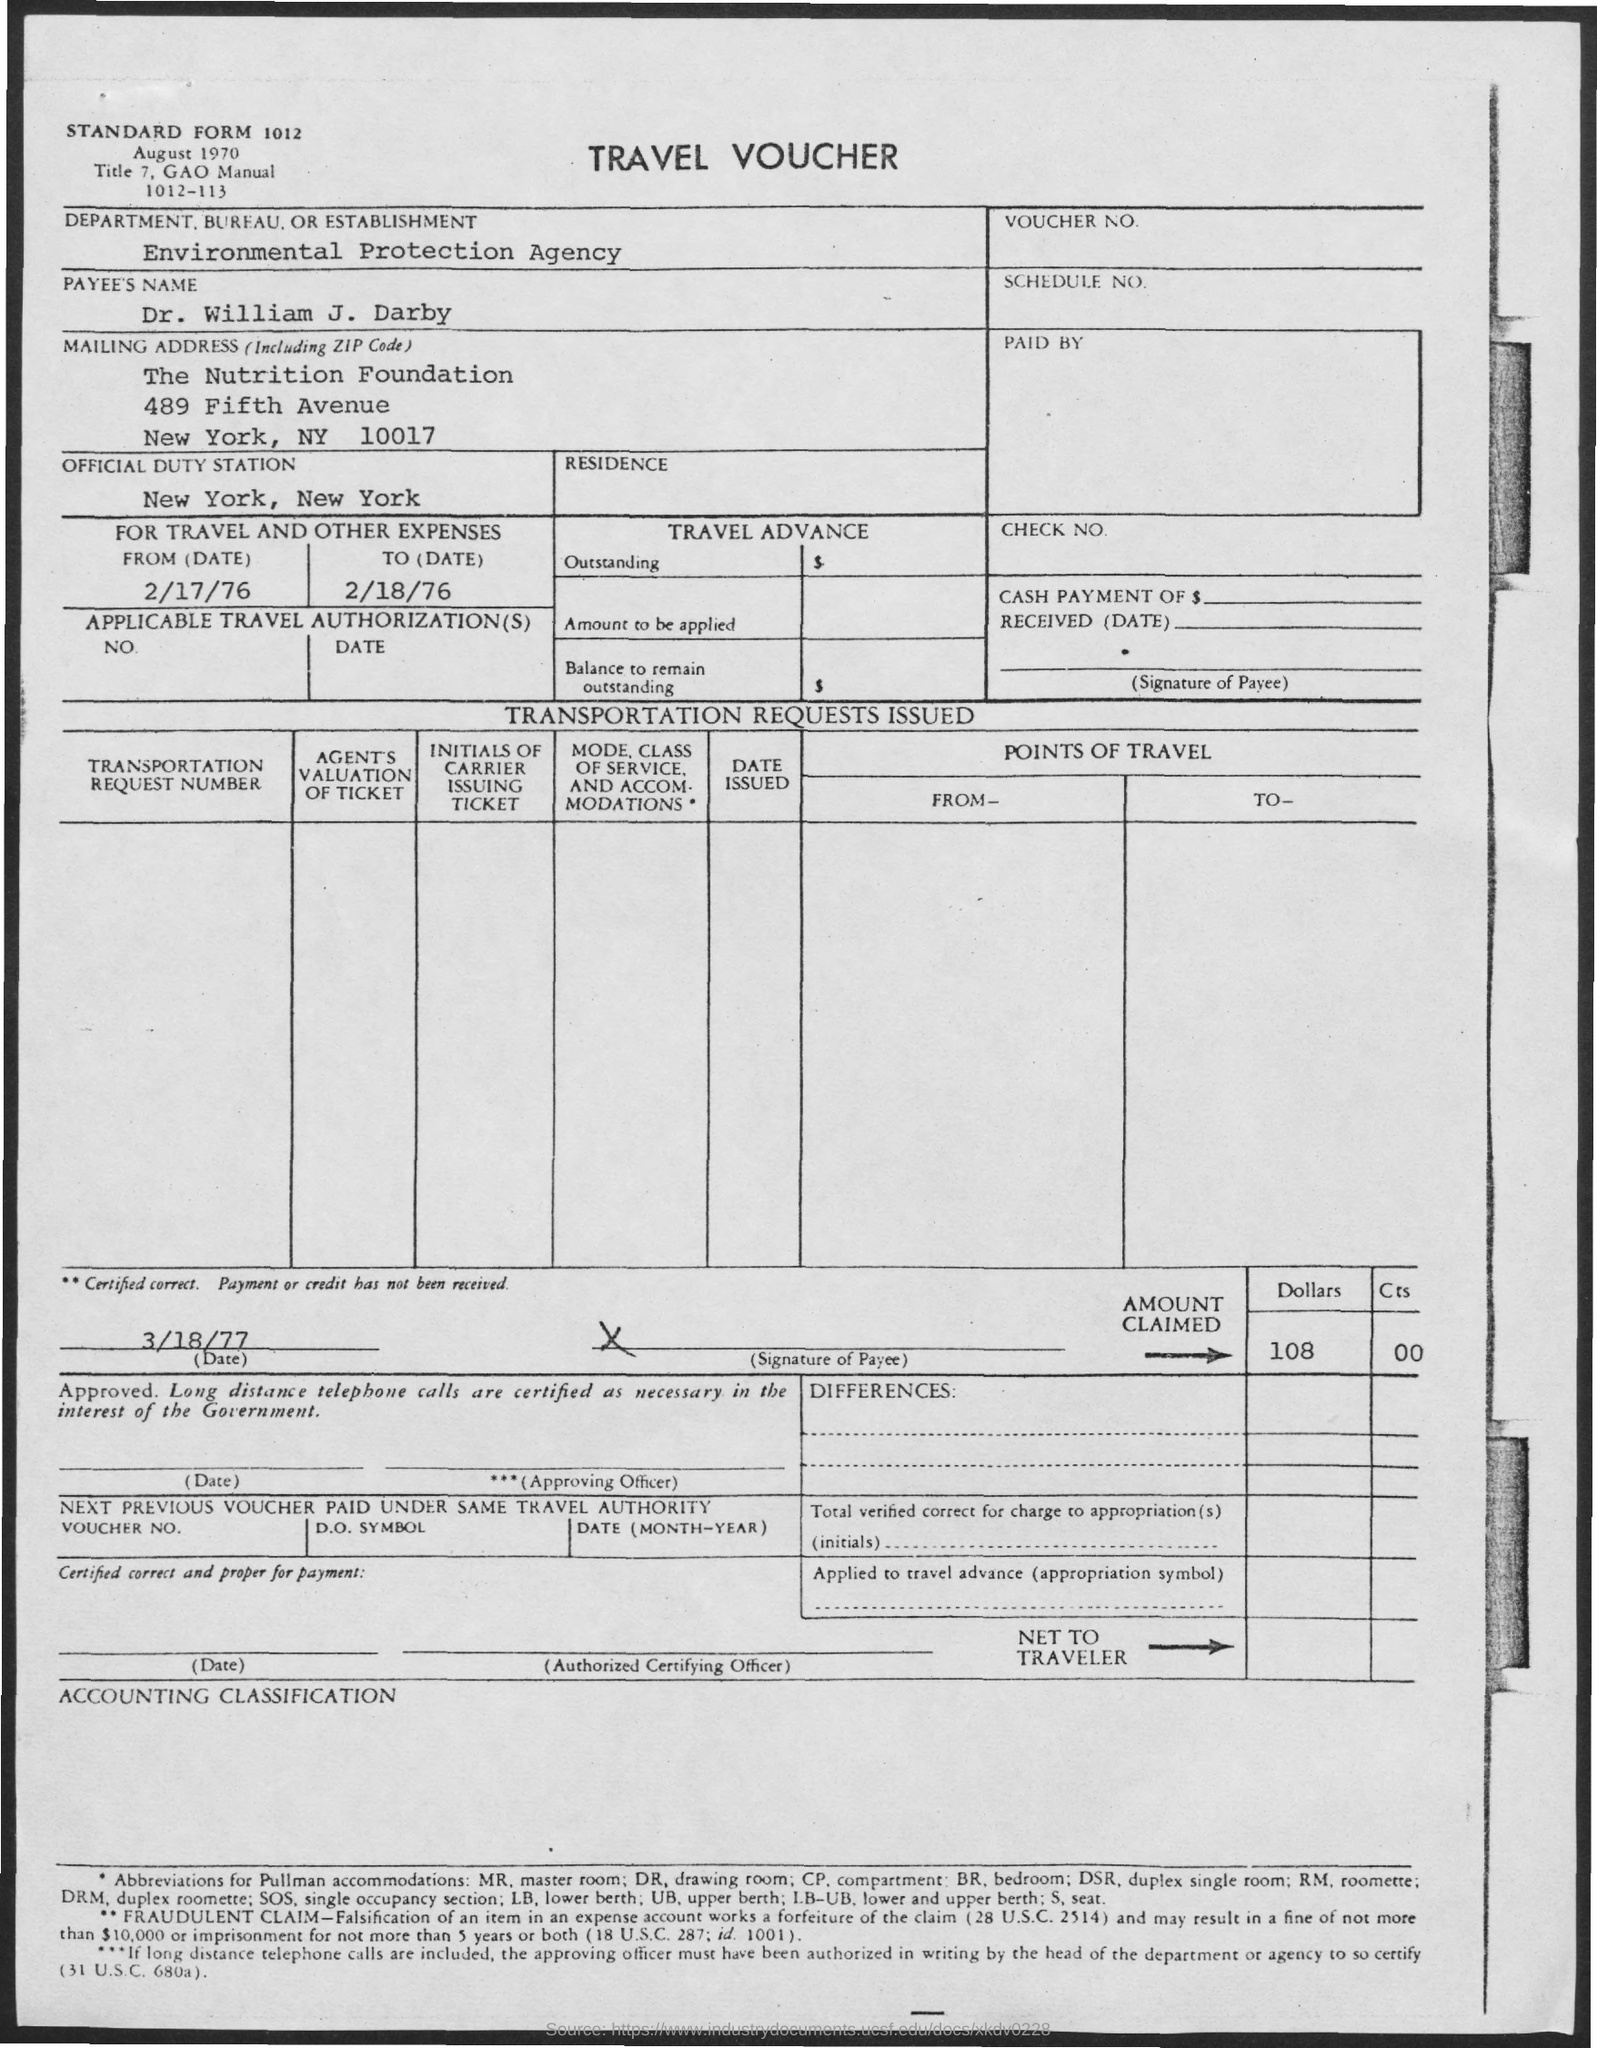Give some essential details in this illustration. This is a travel voucher. 